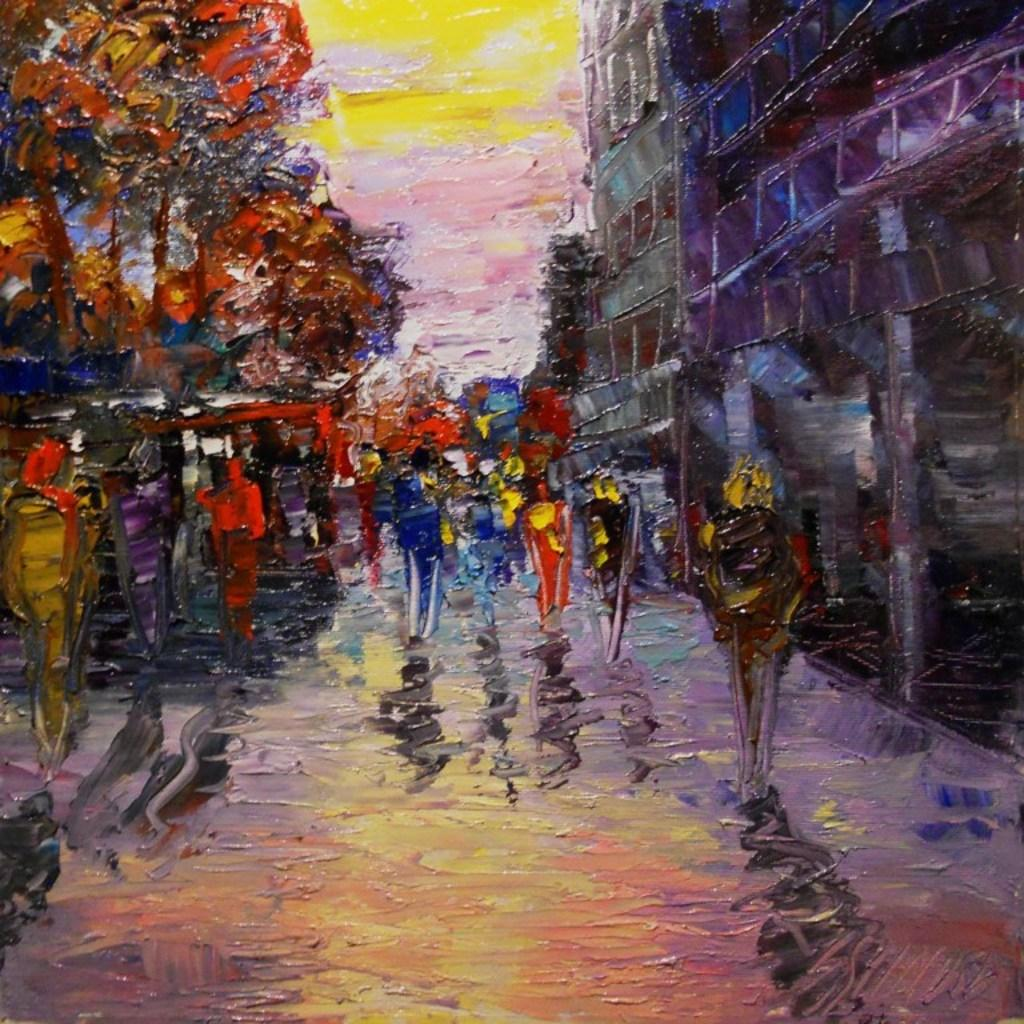What is the main subject of the image? There is a painting in the image. What can be seen beneath the painting? The ground is visible in the image. What type of structure is present in the image? There is a building in the image. What else can be seen in the image besides the painting and building? There are objects in the image. What is visible in the background of the image? The sky is visible in the background of the image. How much money is being exchanged in the image? There is no exchange of money depicted in the image. What type of pleasure can be seen being experienced by the people in the image? There are no people present in the image, so it is impossible to determine if they are experiencing any pleasure. 